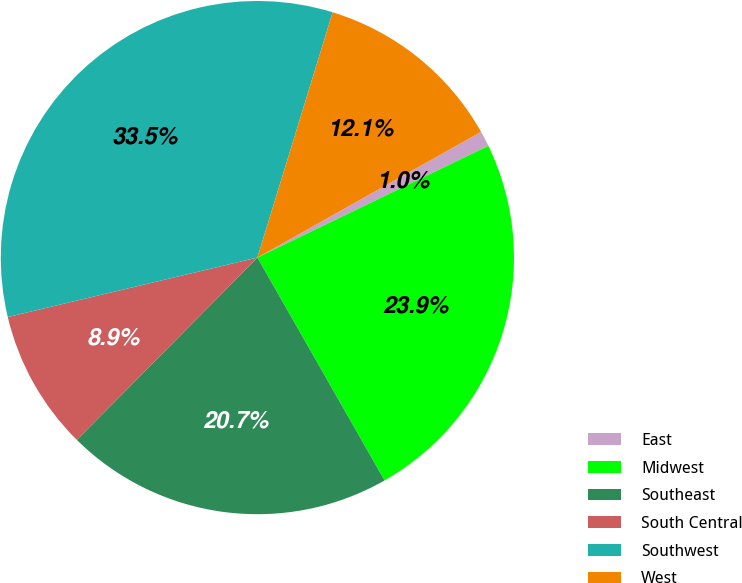Convert chart. <chart><loc_0><loc_0><loc_500><loc_500><pie_chart><fcel>East<fcel>Midwest<fcel>Southeast<fcel>South Central<fcel>Southwest<fcel>West<nl><fcel>0.98%<fcel>23.92%<fcel>20.67%<fcel>8.86%<fcel>33.46%<fcel>12.11%<nl></chart> 